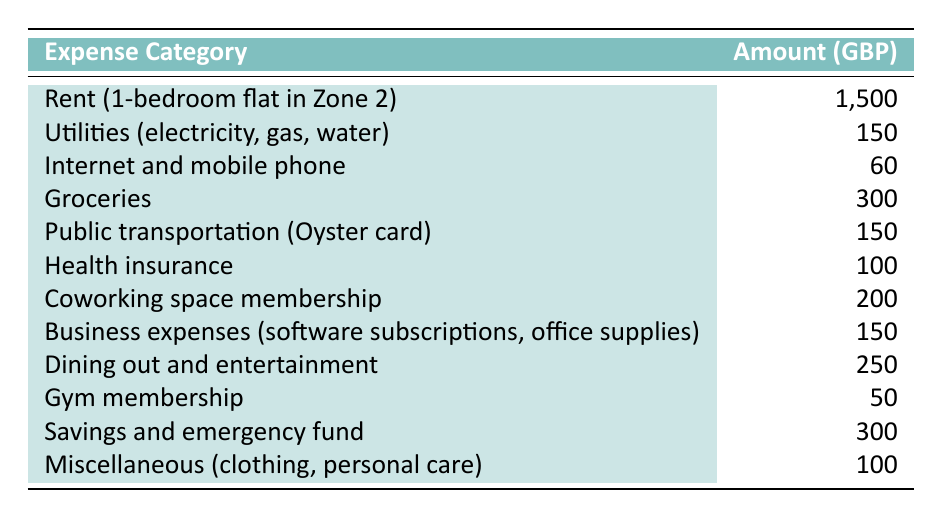What is the highest expense category? The highest expense listed in the table is "Rent (1-bedroom flat in Zone 2)" with an amount of 1,500 GBP.
Answer: 1,500 GBP What is the total amount spent on health-related expenses? The health-related expenses to consider are "Health insurance" (100 GBP) and "Gym membership" (50 GBP). Adding these gives us a total of 100 + 50 = 150 GBP.
Answer: 150 GBP How much does public transportation cost compared to groceries? Public transportation costs 150 GBP while groceries cost 300 GBP. The difference is 300 - 150 = 150 GBP, indicating that groceries cost significantly more.
Answer: Groceries cost 150 GBP more What percentage of the total budget is allocated to savings and emergency funds? First, we need to find the total budget by summing all expenses: 1,500 + 150 + 60 + 300 + 150 + 100 + 200 + 150 + 250 + 50 + 300 + 100 = 3,510 GBP. Savings and emergency funds are 300 GBP. The percentage is (300 / 3,510) * 100 ≈ 8.55%.
Answer: Approximately 8.55% Is the cost of dining out and entertainment higher than that of groceries? Dining out and entertainment costs 250 GBP and groceries cost 300 GBP. Since 250 < 300, we conclude that dining out and entertainment is not higher than groceries.
Answer: No What is the average amount spent on the miscellaneous category and gym membership combined? The "Miscellaneous (clothing, personal care)" is 100 GBP and the "Gym membership" is 50 GBP. Combining these gives us 100 + 50 = 150 GBP. To find the average, we divide by 2 (the number of categories): 150 / 2 = 75 GBP.
Answer: 75 GBP How much less is spent on internet and mobile phone services compared to health insurance? The cost for Internet and mobile phone services is 60 GBP, whereas health insurance costs 100 GBP. The difference is 100 - 60 = 40 GBP.
Answer: 40 GBP What is the total amount allocated to business-related expenses? "Business expenses (software subscriptions, office supplies)" costs 150 GBP and "Coworking space membership" costs 200 GBP. Adding these gives 150 + 200 = 350 GBP.
Answer: 350 GBP What fraction of the total budget is spent on utilities? The total budget is 3,510 GBP (as calculated earlier). The amount for utilities is 150 GBP. The fraction is 150 / 3,510, which simplifies to approximately 0.0427 or 4.27%.
Answer: Approximately 4.27% If the rent increases by 10%, what will the new rent amount be? The current rent is 1,500 GBP. A 10% increase means we multiply 1,500 by 0.10, which gives 150 GBP. Adding this to the original rent gives 1,500 + 150 = 1,650 GBP.
Answer: 1,650 GBP 